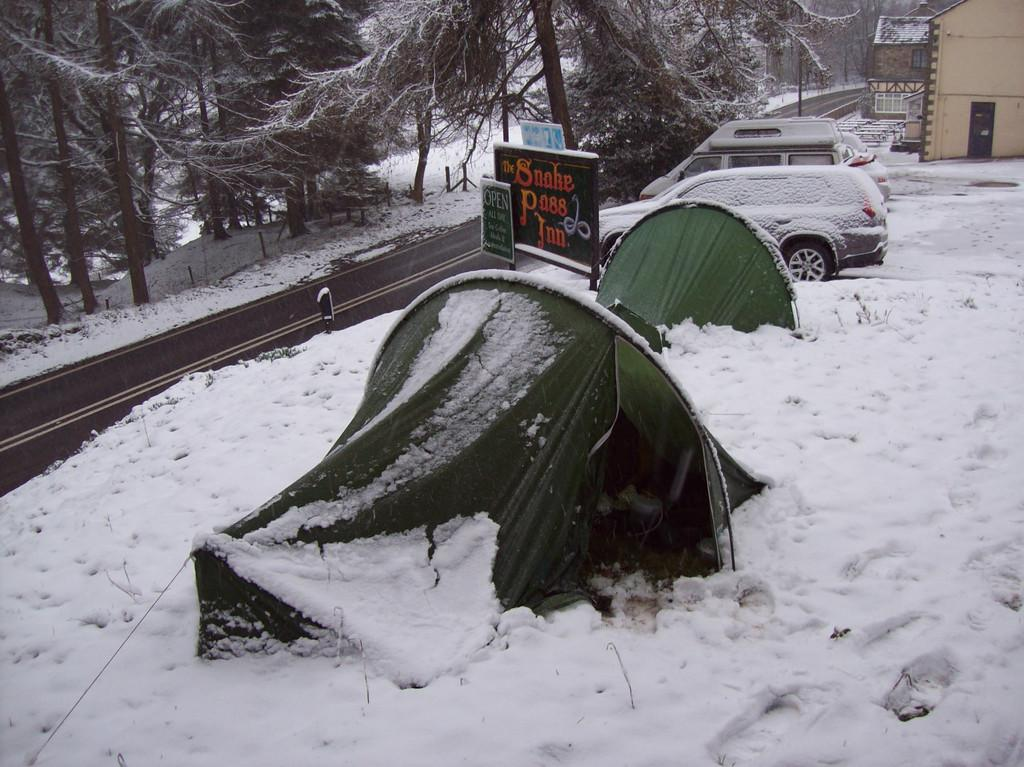<image>
Present a compact description of the photo's key features. A sign in the snow stating that The Snake Pass In is Open. 